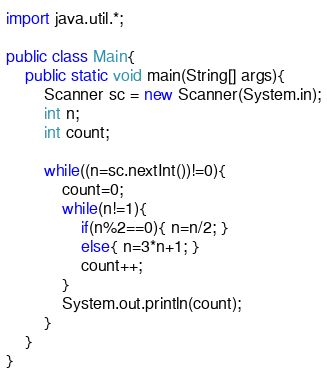Convert code to text. <code><loc_0><loc_0><loc_500><loc_500><_Java_>import java.util.*;

public class Main{
    public static void main(String[] args){
        Scanner sc = new Scanner(System.in);
        int n;
        int count;

        while((n=sc.nextInt())!=0){
            count=0;
            while(n!=1){
                if(n%2==0){ n=n/2; }
                else{ n=3*n+1; }
                count++;
            }
            System.out.println(count);
        }
    }
}
</code> 